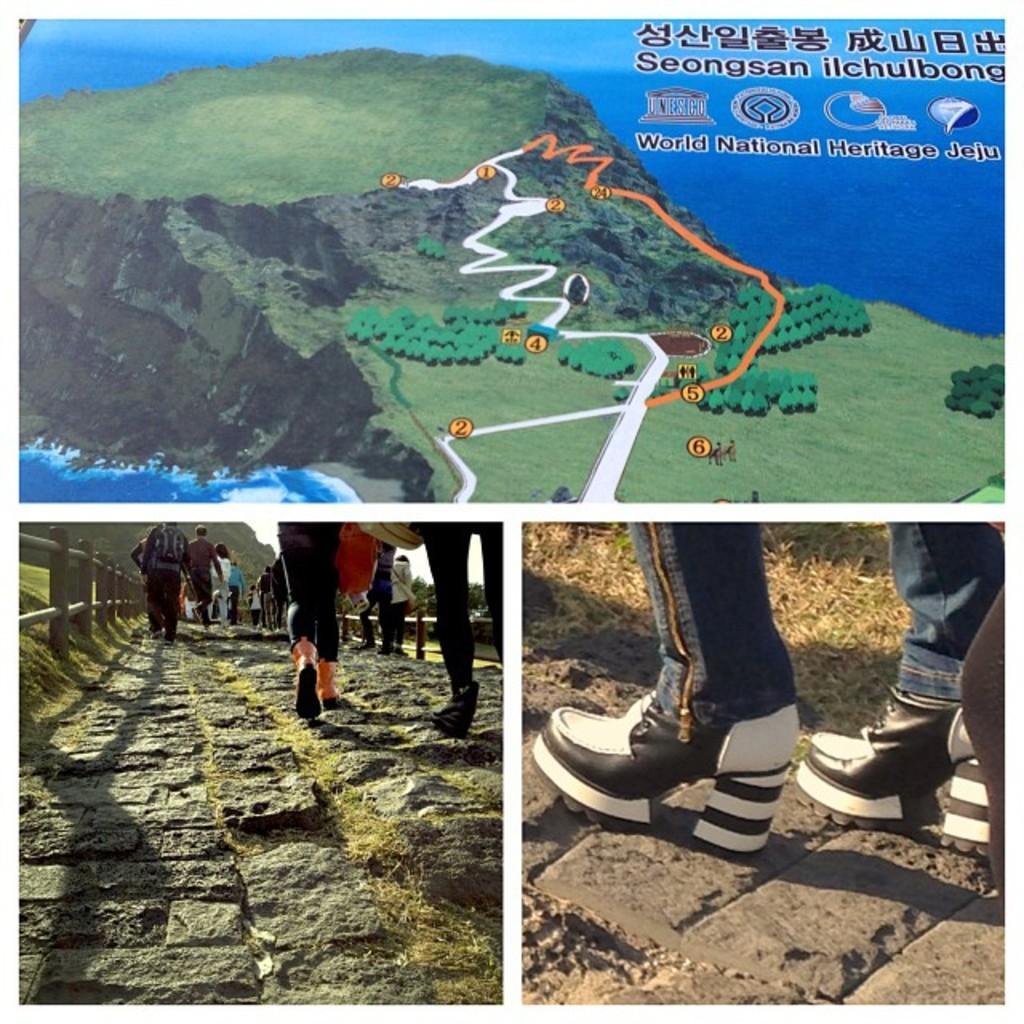Describe this image in one or two sentences. This is an edited image. At the top of the picture, we see the trees and the route map. We even see the water and the sky. In the left bottom, we see people are walking on the road. Beside them, we see the road railing and the grass. In the right bottom, we see the person who is wearing the blue jeans is wearing the black and white shoes. Beside that, we see the grass. 